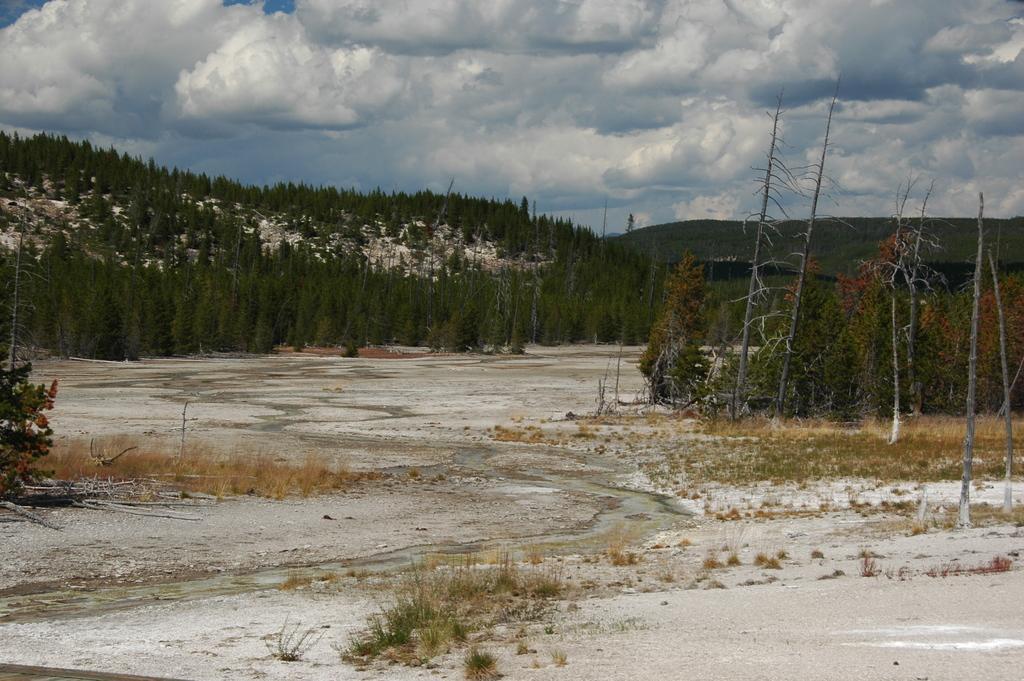Could you give a brief overview of what you see in this image? In this image we can see plants. In the background there are trees. Also there is sky with clouds. 